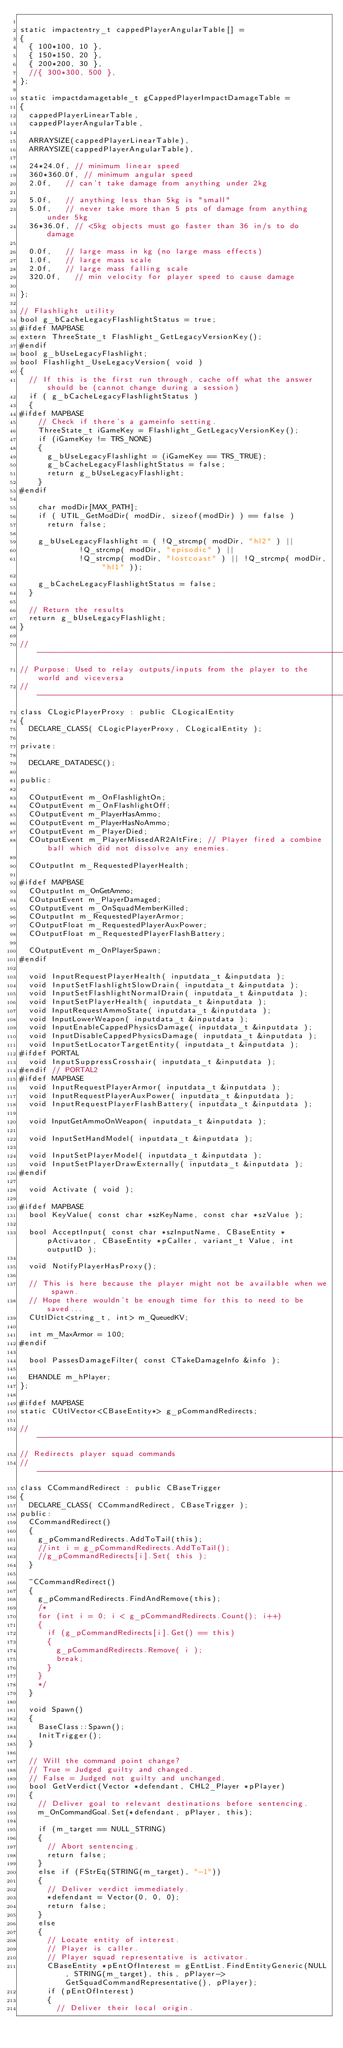Convert code to text. <code><loc_0><loc_0><loc_500><loc_500><_C++_>
static impactentry_t cappedPlayerAngularTable[] =
{
	{ 100*100, 10 },
	{ 150*150, 20 },
	{ 200*200, 30 },
	//{ 300*300, 500 },
};

static impactdamagetable_t gCappedPlayerImpactDamageTable =
{
	cappedPlayerLinearTable,
	cappedPlayerAngularTable,

	ARRAYSIZE(cappedPlayerLinearTable),
	ARRAYSIZE(cappedPlayerAngularTable),

	24*24.0f,	// minimum linear speed
	360*360.0f,	// minimum angular speed
	2.0f,		// can't take damage from anything under 2kg

	5.0f,		// anything less than 5kg is "small"
	5.0f,		// never take more than 5 pts of damage from anything under 5kg
	36*36.0f,	// <5kg objects must go faster than 36 in/s to do damage

	0.0f,		// large mass in kg (no large mass effects)
	1.0f,		// large mass scale
	2.0f,		// large mass falling scale
	320.0f,		// min velocity for player speed to cause damage

};

// Flashlight utility
bool g_bCacheLegacyFlashlightStatus = true;
#ifdef MAPBASE
extern ThreeState_t Flashlight_GetLegacyVersionKey();
#endif
bool g_bUseLegacyFlashlight;
bool Flashlight_UseLegacyVersion( void )
{
	// If this is the first run through, cache off what the answer should be (cannot change during a session)
	if ( g_bCacheLegacyFlashlightStatus )
	{
#ifdef MAPBASE
		// Check if there's a gameinfo setting.
		ThreeState_t iGameKey = Flashlight_GetLegacyVersionKey();
		if (iGameKey != TRS_NONE)
		{
			g_bUseLegacyFlashlight = (iGameKey == TRS_TRUE);
			g_bCacheLegacyFlashlightStatus = false;
			return g_bUseLegacyFlashlight;
		}
#endif

		char modDir[MAX_PATH];
		if ( UTIL_GetModDir( modDir, sizeof(modDir) ) == false )
			return false;

		g_bUseLegacyFlashlight = ( !Q_strcmp( modDir, "hl2" ) ||
					   !Q_strcmp( modDir, "episodic" ) ||
					   !Q_strcmp( modDir, "lostcoast" ) || !Q_strcmp( modDir, "hl1" ));

		g_bCacheLegacyFlashlightStatus = false;
	}

	// Return the results
	return g_bUseLegacyFlashlight;
}

//-----------------------------------------------------------------------------
// Purpose: Used to relay outputs/inputs from the player to the world and viceversa
//-----------------------------------------------------------------------------
class CLogicPlayerProxy : public CLogicalEntity
{
	DECLARE_CLASS( CLogicPlayerProxy, CLogicalEntity );

private:

	DECLARE_DATADESC();

public:

	COutputEvent m_OnFlashlightOn;
	COutputEvent m_OnFlashlightOff;
	COutputEvent m_PlayerHasAmmo;
	COutputEvent m_PlayerHasNoAmmo;
	COutputEvent m_PlayerDied;
	COutputEvent m_PlayerMissedAR2AltFire; // Player fired a combine ball which did not dissolve any enemies. 

	COutputInt m_RequestedPlayerHealth;

#ifdef MAPBASE
	COutputInt m_OnGetAmmo;
	COutputEvent m_PlayerDamaged;
	COutputEvent m_OnSquadMemberKilled;
	COutputInt m_RequestedPlayerArmor;
	COutputFloat m_RequestedPlayerAuxPower;
	COutputFloat m_RequestedPlayerFlashBattery;

	COutputEvent m_OnPlayerSpawn;
#endif

	void InputRequestPlayerHealth( inputdata_t &inputdata );
	void InputSetFlashlightSlowDrain( inputdata_t &inputdata );
	void InputSetFlashlightNormalDrain( inputdata_t &inputdata );
	void InputSetPlayerHealth( inputdata_t &inputdata );
	void InputRequestAmmoState( inputdata_t &inputdata );
	void InputLowerWeapon( inputdata_t &inputdata );
	void InputEnableCappedPhysicsDamage( inputdata_t &inputdata );
	void InputDisableCappedPhysicsDamage( inputdata_t &inputdata );
	void InputSetLocatorTargetEntity( inputdata_t &inputdata );
#ifdef PORTAL
	void InputSuppressCrosshair( inputdata_t &inputdata );
#endif // PORTAL2
#ifdef MAPBASE
	void InputRequestPlayerArmor( inputdata_t &inputdata );
	void InputRequestPlayerAuxPower( inputdata_t &inputdata );
	void InputRequestPlayerFlashBattery( inputdata_t &inputdata );

	void InputGetAmmoOnWeapon( inputdata_t &inputdata );

	void InputSetHandModel( inputdata_t &inputdata );

	void InputSetPlayerModel( inputdata_t &inputdata );
	void InputSetPlayerDrawExternally( inputdata_t &inputdata );
#endif

	void Activate ( void );

#ifdef MAPBASE
	bool KeyValue( const char *szKeyName, const char *szValue );

	bool AcceptInput( const char *szInputName, CBaseEntity *pActivator, CBaseEntity *pCaller, variant_t Value, int outputID );

	void NotifyPlayerHasProxy();

	// This is here because the player might not be available when we spawn.
	// Hope there wouldn't be enough time for this to need to be saved...
	CUtlDict<string_t, int> m_QueuedKV;

	int m_MaxArmor = 100;
#endif

	bool PassesDamageFilter( const CTakeDamageInfo &info );

	EHANDLE m_hPlayer;
};

#ifdef MAPBASE
static CUtlVector<CBaseEntity*> g_pCommandRedirects;

//-----------------------------------------------------------------------------
// Redirects player squad commands
//-----------------------------------------------------------------------------
class CCommandRedirect : public CBaseTrigger
{
	DECLARE_CLASS( CCommandRedirect, CBaseTrigger );
public:
	CCommandRedirect()
	{
		g_pCommandRedirects.AddToTail(this);
		//int i = g_pCommandRedirects.AddToTail();
		//g_pCommandRedirects[i].Set( this );
	}

	~CCommandRedirect()
	{
		g_pCommandRedirects.FindAndRemove(this);
		/*
		for (int i = 0; i < g_pCommandRedirects.Count(); i++)
		{
			if (g_pCommandRedirects[i].Get() == this)
			{
				g_pCommandRedirects.Remove( i );
				break;
			}
		}
		*/
	}

	void Spawn()
	{
		BaseClass::Spawn();
		InitTrigger();
	}

	// Will the command point change?
	// True = Judged guilty and changed.
	// False = Judged not guilty and unchanged.
	bool GetVerdict(Vector *defendant, CHL2_Player *pPlayer)
	{
		// Deliver goal to relevant destinations before sentencing.
		m_OnCommandGoal.Set(*defendant, pPlayer, this);

		if (m_target == NULL_STRING)
		{
			// Abort sentencing.
			return false;
		}
		else if (FStrEq(STRING(m_target), "-1"))
		{
			// Deliver verdict immediately.
			*defendant = Vector(0, 0, 0);
			return false;
		}
		else
		{
			// Locate entity of interest.
			// Player is caller.
			// Player squad representative is activator.
			CBaseEntity *pEntOfInterest = gEntList.FindEntityGeneric(NULL, STRING(m_target), this, pPlayer->GetSquadCommandRepresentative(), pPlayer);
			if (pEntOfInterest)
			{
				// Deliver their local origin.</code> 